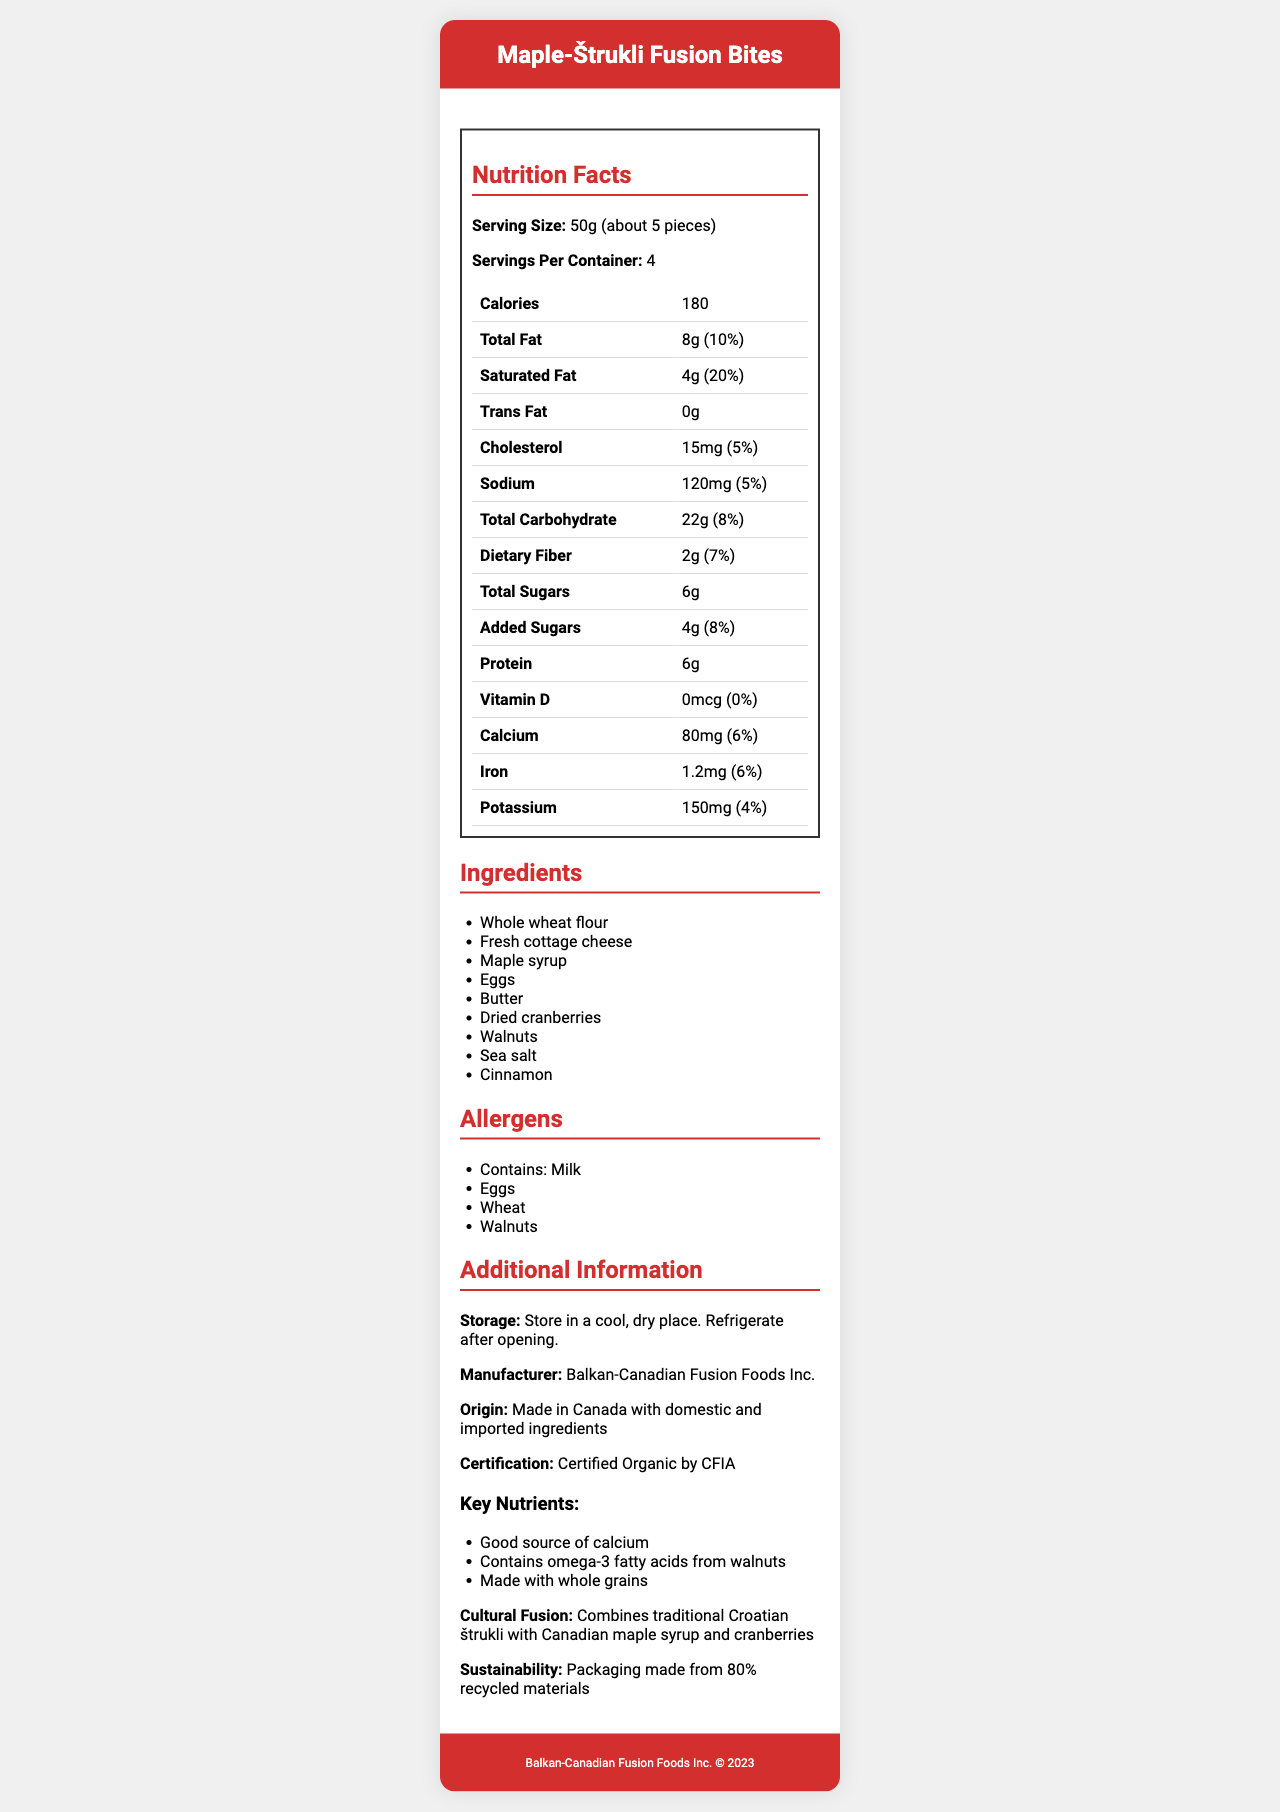what is the serving size? The document states the serving size is 50g, which is approximately 5 pieces.
Answer: 50g (about 5 pieces) how many calories are in one serving? The Nutrition Facts section lists that there are 180 calories per serving.
Answer: 180 what is the percentage of daily value for total fat per serving? The label indicates that the daily value for total fat is 10%.
Answer: 10% what are the key nutrients mentioned in the additional info section? The additional info section highlights these key nutrients.
Answer: Good source of calcium, Contains omega-3 fatty acids from walnuts, Made with whole grains which allergen is not listed in the document? A. Milk B. Soy C. Eggs D. Wheat The allergens listed are Milk, Eggs, Wheat, and Walnuts. Soy is not mentioned.
Answer: B what is the manufacturer's name? The manufacturer is listed as Balkan-Canadian Fusion Foods Inc.
Answer: Balkan-Canadian Fusion Foods Inc. where should you store the product after opening? The storage instruction states to store the product in a cool, dry place and refrigerate after opening.
Answer: Refrigerate after opening how much protein is in one serving? The Nutrition Facts section lists 6g of protein per serving.
Answer: 6g from which ingredients does the snack contain omega-3 fatty acids? A. Walnuts B. Maple syrup C. Eggs The additional info section states that the snack contains omega-3 fatty acids from walnuts.
Answer: A how many milligrams of potassium are in one serving? The nutrition label states there are 150mg of potassium per serving.
Answer: 150mg what cultural fusion does this product represent? The additional info section describes the cultural fusion of traditional Croatian štrukli with Canadian flavors.
Answer: Combines traditional Croatian štrukli with Canadian maple syrup and cranberries is the product certified organic? The document states that the product is Certified Organic by CFIA.
Answer: Yes what percentage of the packaging is made from recycled materials? The additional info section mentions that the packaging is made from 80% recycled materials.
Answer: 80% how much-added sugar does one serving contain? The label indicates that there are 4g of added sugars per serving.
Answer: 4g how many servings are in one container? The Nutrition Facts section states that there are 4 servings per container.
Answer: 4 what is the total carbohydrate content per serving? The nutrition label indicates that the total carbohydrate content per serving is 22g.
Answer: 22g how much vitamin D is provided in each serving? The label states that there is 0mcg of vitamin D per serving.
Answer: 0mcg what nutritional benefit is provided by walnuts in this snack? The additional info section states that walnuts contribute omega-3 fatty acids.
Answer: Omega-3 fatty acids describe the main idea of the document. The document details the nutritional content, ingredients, allergens, storage instructions, manufacturer's information, and key benefits of Maple-Štrukli Fusion Bites.
Answer: The document provides nutrition facts, ingredients, allergens, and additional information for Maple-Štrukli Fusion Bites, a snack combining Croatian and Canadian flavors with an emphasis on nutrient density. what is the vitamin B12 content per serving? The document does not mention the content of vitamin B12.
Answer: Not enough information 